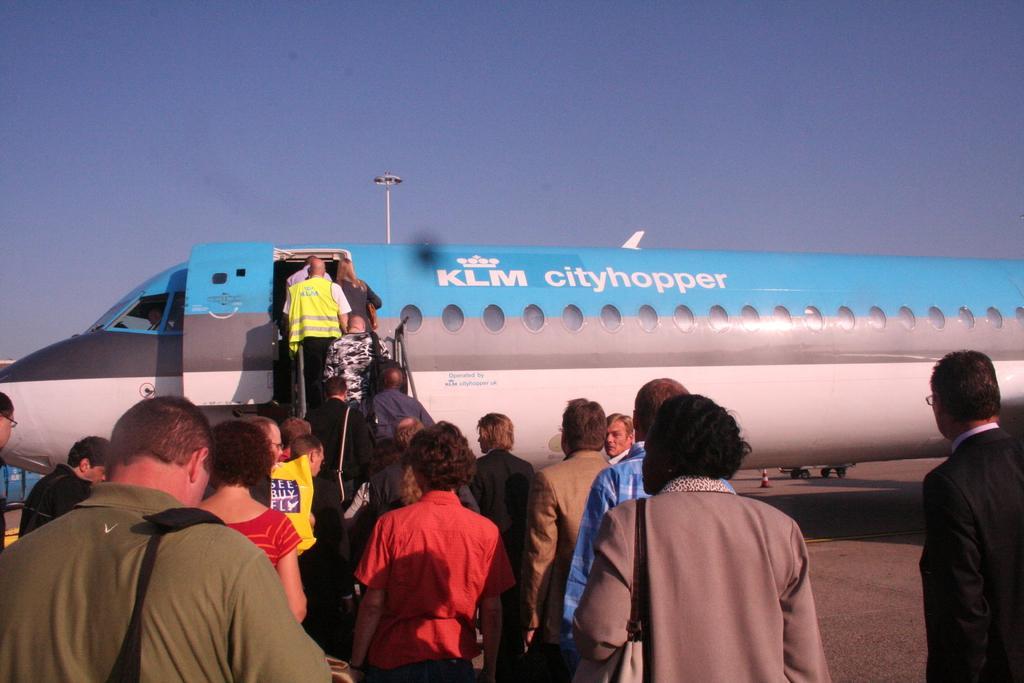Please provide a concise description of this image. In the image there is an airplane and the people are boarding into the plane. 